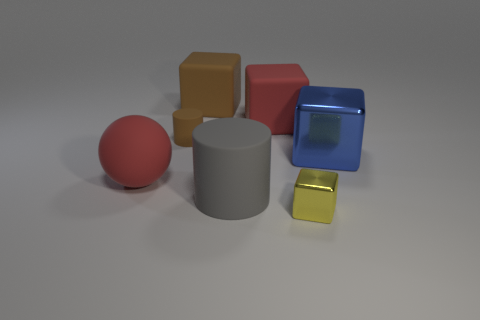Subtract 2 blocks. How many blocks are left? 2 Subtract all large brown blocks. How many blocks are left? 3 Subtract all red cubes. How many cubes are left? 3 Add 2 blue metal cubes. How many objects exist? 9 Subtract all gray cubes. Subtract all gray balls. How many cubes are left? 4 Subtract all cubes. How many objects are left? 3 Add 7 big gray rubber things. How many big gray rubber things exist? 8 Subtract 0 purple balls. How many objects are left? 7 Subtract all large blue objects. Subtract all large metal things. How many objects are left? 5 Add 3 large red objects. How many large red objects are left? 5 